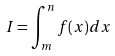<formula> <loc_0><loc_0><loc_500><loc_500>I = \int _ { m } ^ { n } f ( x ) d x</formula> 